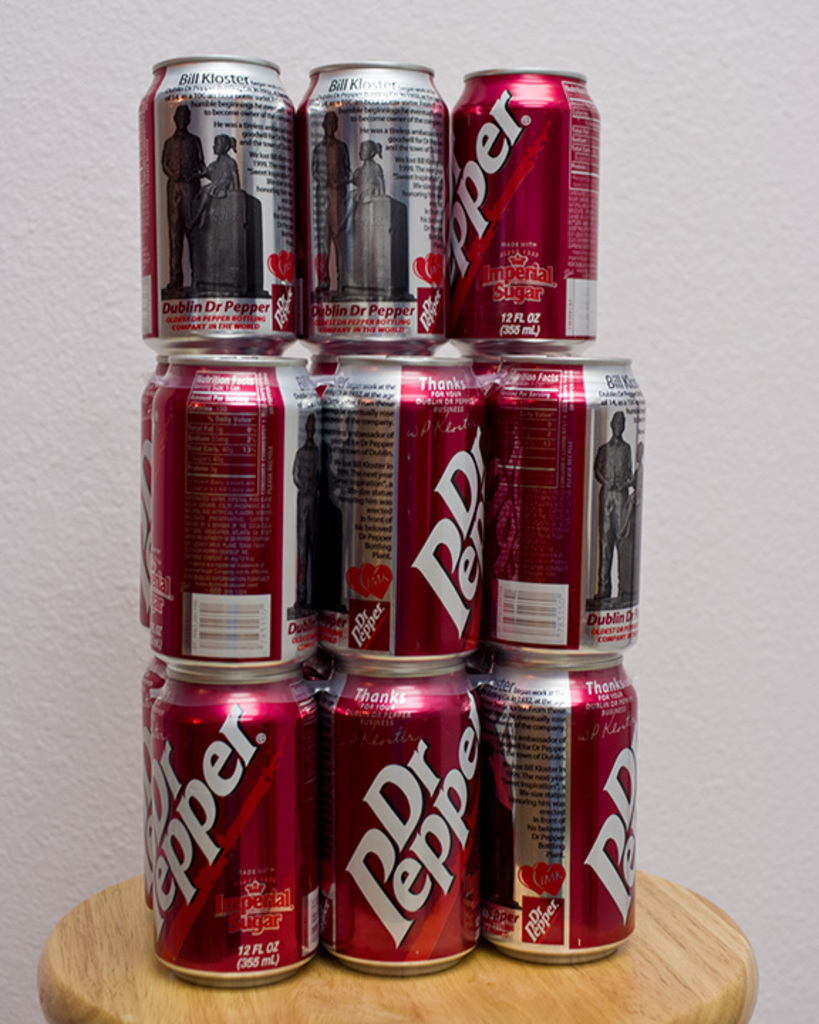What makes these Dr Pepper cans unique compared to regular ones? These cans are unique as they bear the 'Dublin Dr Pepper' label, which was a special version made with pure cane sugar instead of high fructose corn syrup, making them a collectible among soda enthusiasts. 